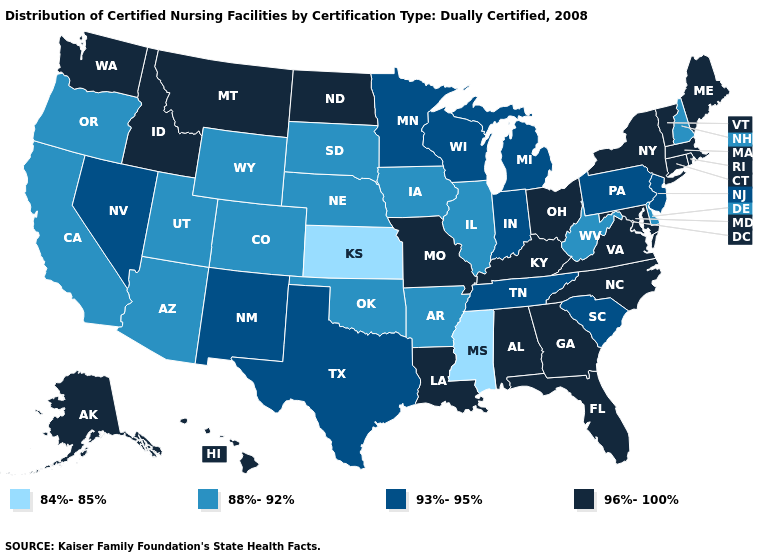Among the states that border Connecticut , which have the highest value?
Write a very short answer. Massachusetts, New York, Rhode Island. What is the value of Nebraska?
Concise answer only. 88%-92%. Name the states that have a value in the range 84%-85%?
Answer briefly. Kansas, Mississippi. Is the legend a continuous bar?
Write a very short answer. No. Name the states that have a value in the range 96%-100%?
Quick response, please. Alabama, Alaska, Connecticut, Florida, Georgia, Hawaii, Idaho, Kentucky, Louisiana, Maine, Maryland, Massachusetts, Missouri, Montana, New York, North Carolina, North Dakota, Ohio, Rhode Island, Vermont, Virginia, Washington. Name the states that have a value in the range 93%-95%?
Keep it brief. Indiana, Michigan, Minnesota, Nevada, New Jersey, New Mexico, Pennsylvania, South Carolina, Tennessee, Texas, Wisconsin. Does West Virginia have a higher value than Pennsylvania?
Give a very brief answer. No. Does Vermont have the lowest value in the USA?
Give a very brief answer. No. Which states hav the highest value in the MidWest?
Short answer required. Missouri, North Dakota, Ohio. What is the value of Florida?
Concise answer only. 96%-100%. What is the value of New Jersey?
Short answer required. 93%-95%. What is the highest value in states that border Nebraska?
Quick response, please. 96%-100%. What is the value of Arkansas?
Give a very brief answer. 88%-92%. Does the map have missing data?
Answer briefly. No. Name the states that have a value in the range 88%-92%?
Give a very brief answer. Arizona, Arkansas, California, Colorado, Delaware, Illinois, Iowa, Nebraska, New Hampshire, Oklahoma, Oregon, South Dakota, Utah, West Virginia, Wyoming. 